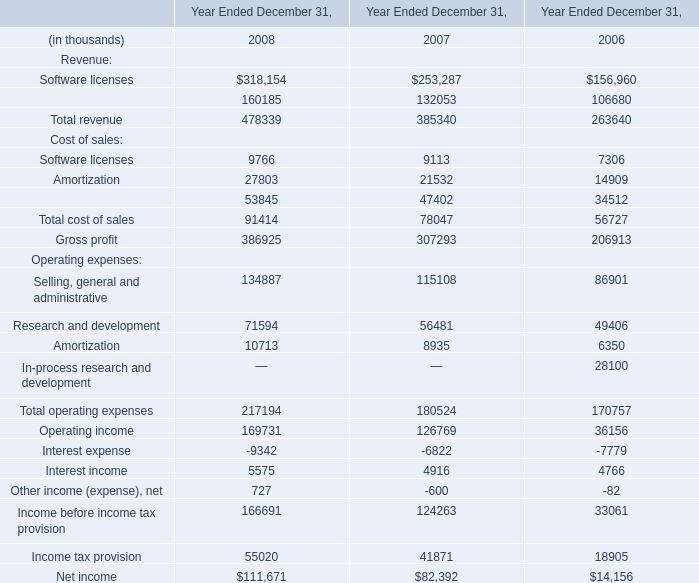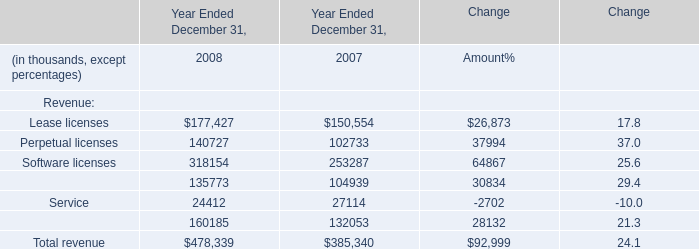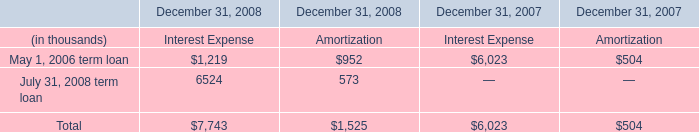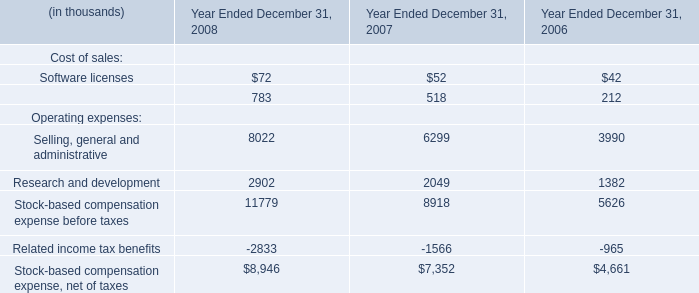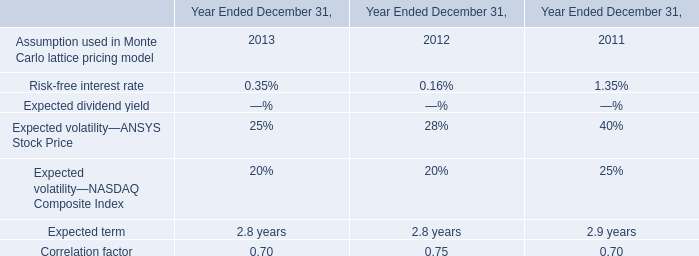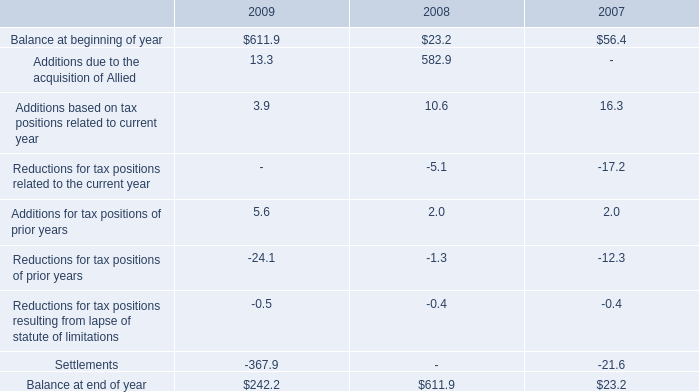What's the sum of the Maintenance in the years where Service is positive? (in thousand) 
Computations: (135773 + 104939)
Answer: 240712.0. 